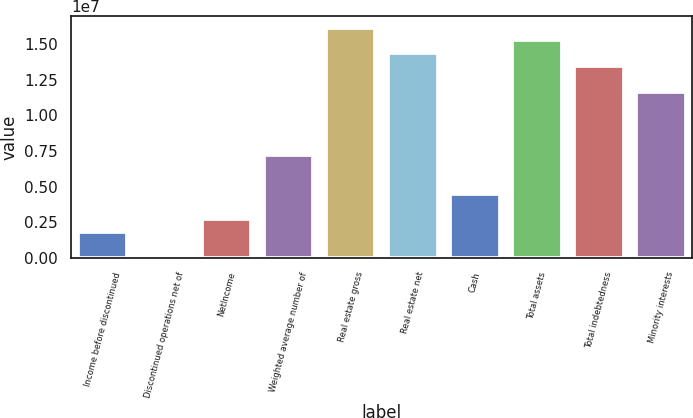Convert chart to OTSL. <chart><loc_0><loc_0><loc_500><loc_500><bar_chart><fcel>Income before discontinued<fcel>Discontinued operations net of<fcel>NetIncome<fcel>Weighted average number of<fcel>Real estate gross<fcel>Real estate net<fcel>Cash<fcel>Total assets<fcel>Total indebtedness<fcel>Minority interests<nl><fcel>1.79665e+06<fcel>0.81<fcel>2.69498e+06<fcel>7.18661e+06<fcel>1.61699e+07<fcel>1.43732e+07<fcel>4.49163e+06<fcel>1.52715e+07<fcel>1.34749e+07<fcel>1.16782e+07<nl></chart> 